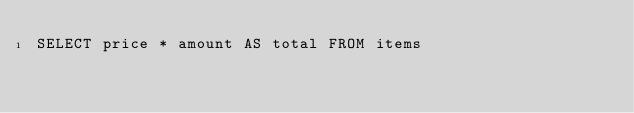Convert code to text. <code><loc_0><loc_0><loc_500><loc_500><_SQL_>SELECT price * amount AS total FROM items
</code> 